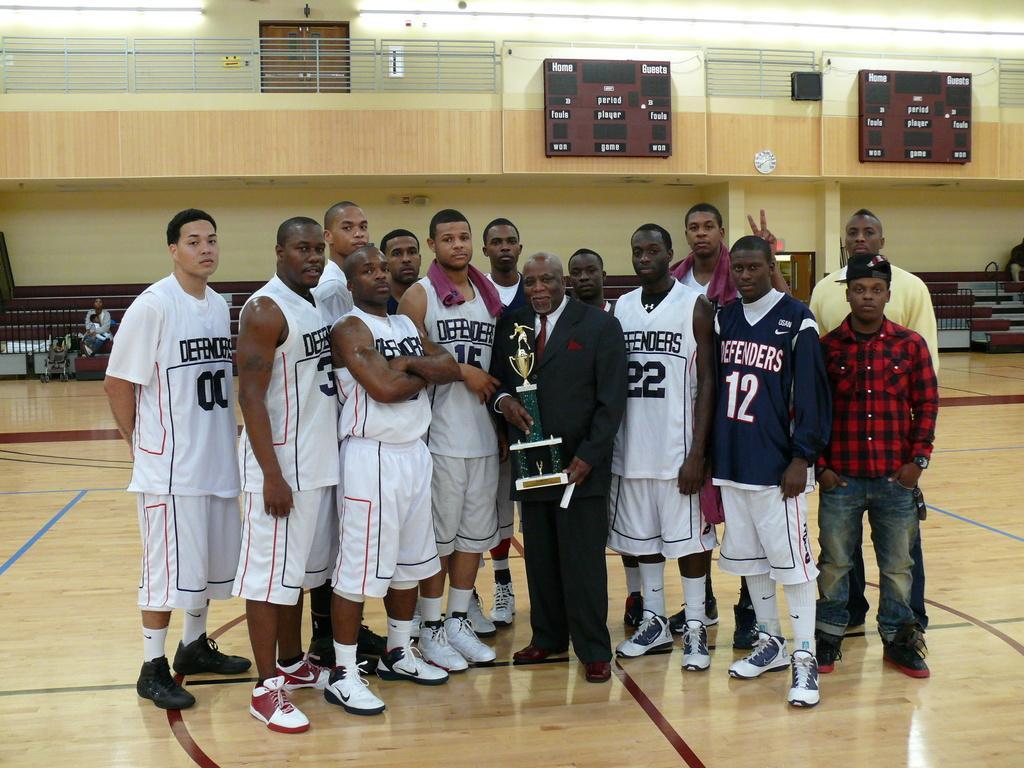Describe this image in one or two sentences. There is a person holding a trophy in the foreground area of the image and boys standing in the center, there are people, boards, boundary, door and light in the background. 